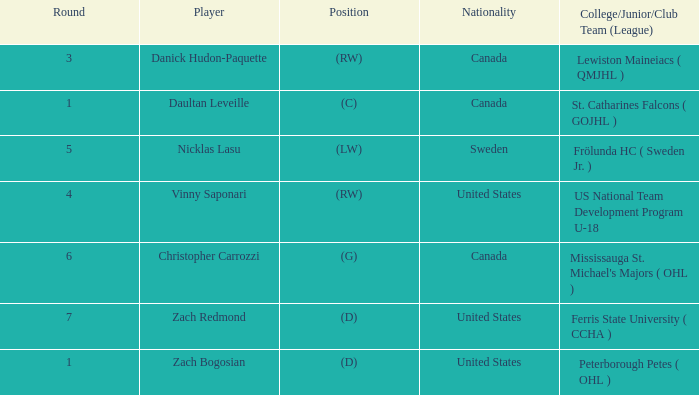What is Daultan Leveille's Position? (C). 